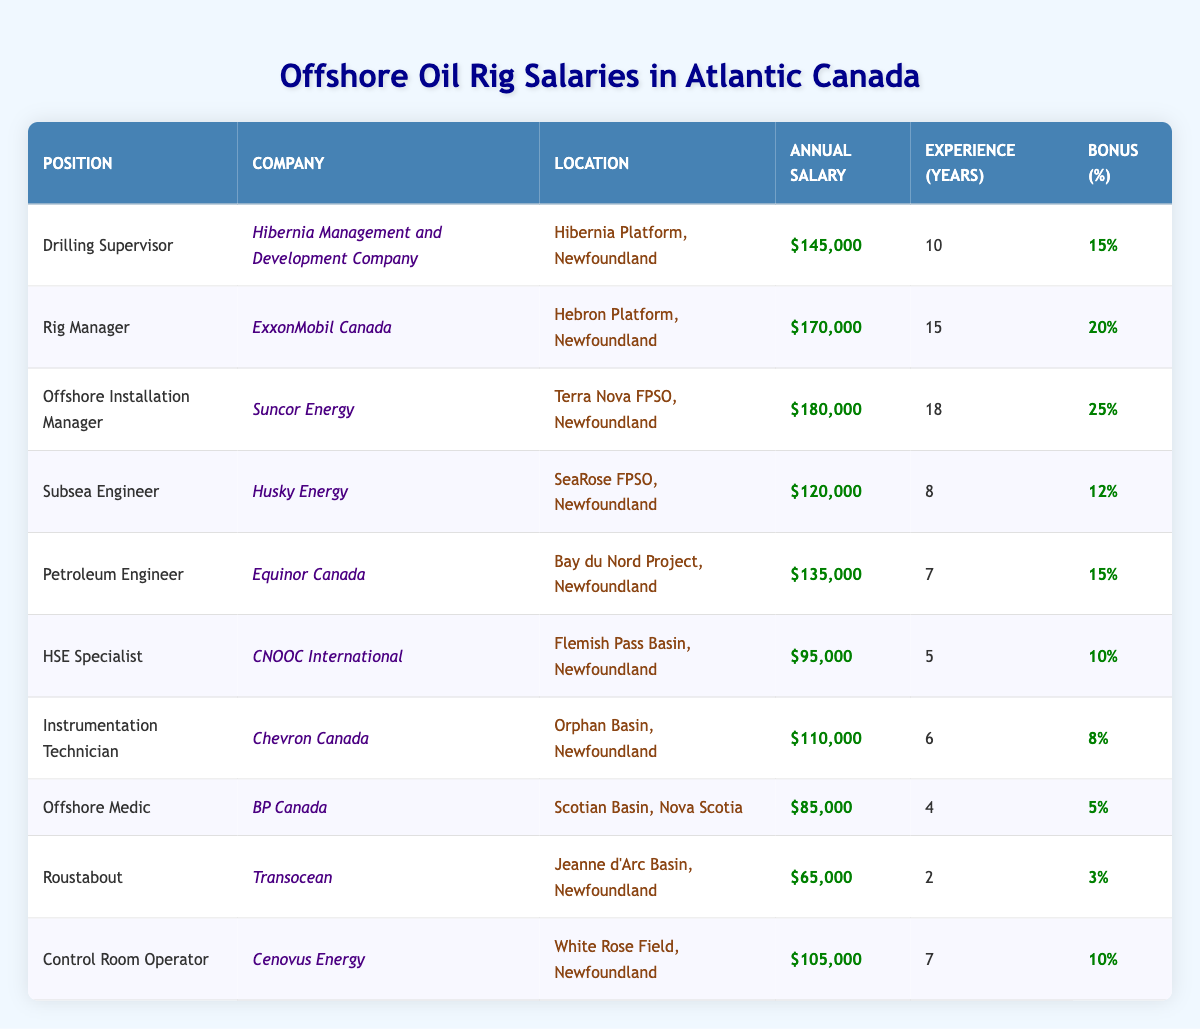What is the highest annual salary among the positions listed? The "Offshore Installation Manager" position at "Suncor Energy" has the highest annual salary of $180,000.
Answer: $180,000 What is the average annual salary for the positions in Newfoundland? The positions in Newfoundland are: Drilling Supervisor ($145,000), Rig Manager ($170,000), Offshore Installation Manager ($180,000), Subsea Engineer ($120,000), Petroleum Engineer ($135,000), HSE Specialist ($95,000), Instrumentation Technician ($110,000), Roustabout ($65,000), Control Room Operator ($105,000). The total is $1,155,000 and there are 9 positions, so the average is $1,155,000 / 9 = $128,333.33.
Answer: $128,333.33 Is the annual salary for the Offshore Medic position above $80,000? The Offshore Medic position has an annual salary of $85,000, which is above $80,000.
Answer: Yes Which position has the maximum bonus percentage and what is the value? The "Offshore Installation Manager" has the maximum bonus percentage of 25%.
Answer: 25% Are there any positions with more than 10 years of experience that have an annual salary below $120,000? The positions with more than 10 years of experience are: Drilling Supervisor (10 years, $145,000), Rig Manager (15 years, $170,000), Offshore Installation Manager (18 years, $180,000), Subsea Engineer (8 years, $120,000), Petroleum Engineer (7 years, $135,000). There are no positions meeting the criteria of more than 10 years of experience with a salary below $120,000.
Answer: No What is the total bonus percentage of all positions combined? The bonus percentages are: 15%, 20%, 25%, 12%, 15%, 10%, 8%, 5%, 3%, 10%. Adding these gives 15 + 20 + 25 + 12 + 15 + 10 + 8 + 5 + 3 + 10 = 118%.
Answer: 118% How many companies are listed from Newfoundland? The companies listed in Newfoundland are: Hibernia Management and Development Company, ExxonMobil Canada, Suncor Energy, Husky Energy, Equinor Canada, CNOOC International, Chevron Canada, Transocean, and Cenovus Energy. There are 9 companies in total.
Answer: 9 What is the median annual salary in the table? The sorted annual salaries are: $65,000, $85,000, $95,000, $110,000, $120,000, $135,000, $145,000, $170,000, $180,000. The median is the middle value in this sorted list. Since there are 10 values, the median is the average of the 5th and 6th values: ($120,000 + $135,000) / 2 = $127,500.
Answer: $127,500 